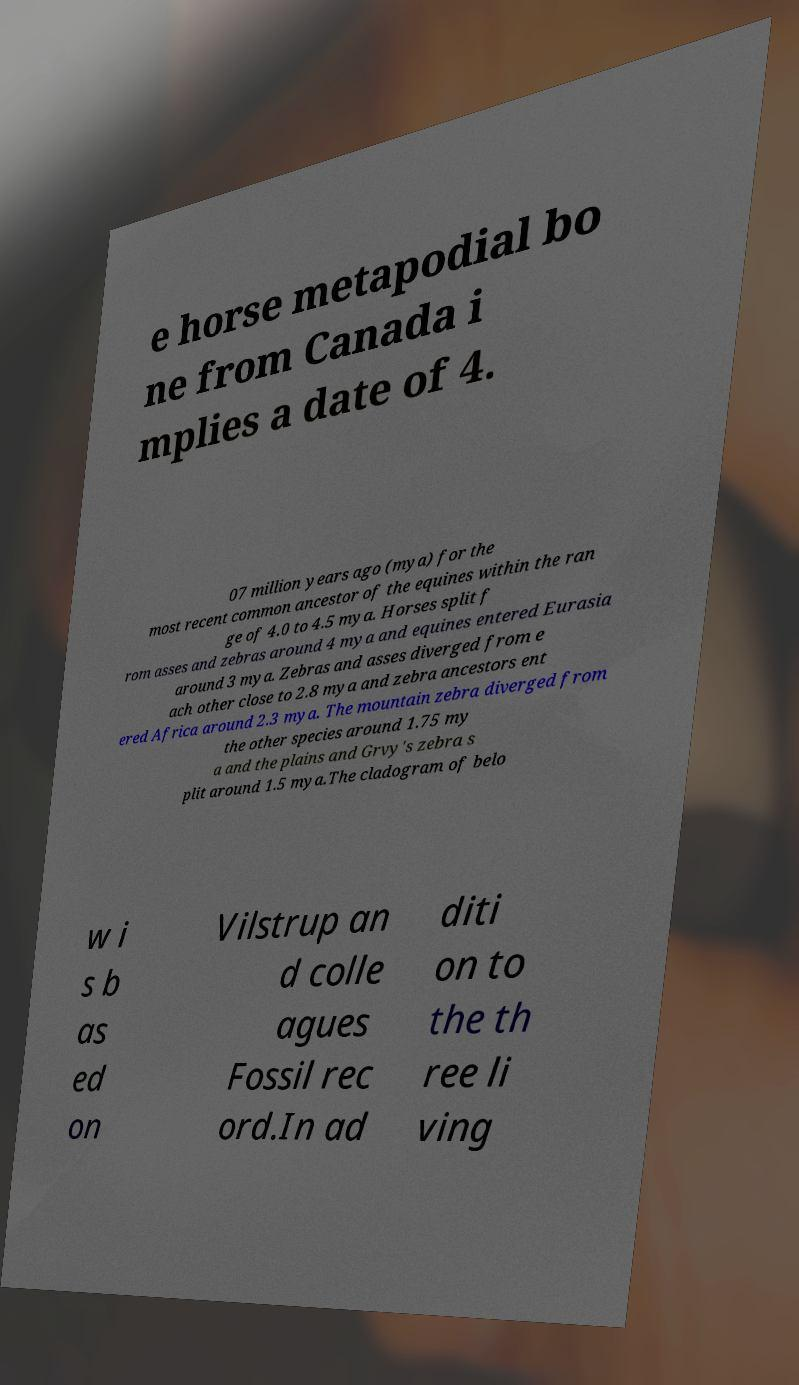Please read and relay the text visible in this image. What does it say? e horse metapodial bo ne from Canada i mplies a date of 4. 07 million years ago (mya) for the most recent common ancestor of the equines within the ran ge of 4.0 to 4.5 mya. Horses split f rom asses and zebras around 4 mya and equines entered Eurasia around 3 mya. Zebras and asses diverged from e ach other close to 2.8 mya and zebra ancestors ent ered Africa around 2.3 mya. The mountain zebra diverged from the other species around 1.75 my a and the plains and Grvy's zebra s plit around 1.5 mya.The cladogram of belo w i s b as ed on Vilstrup an d colle agues Fossil rec ord.In ad diti on to the th ree li ving 